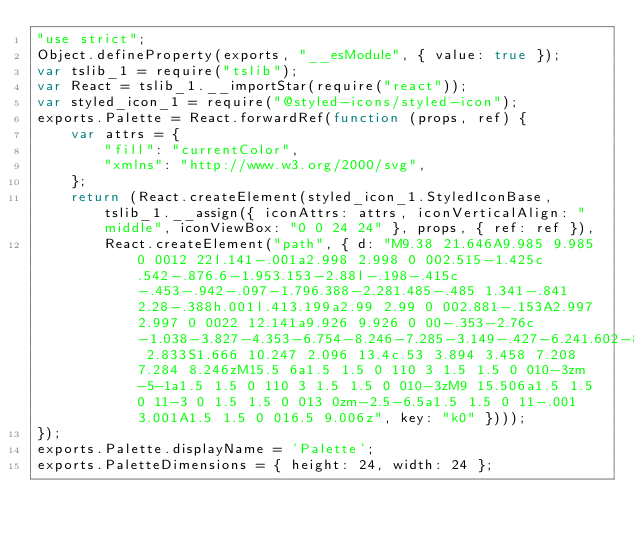<code> <loc_0><loc_0><loc_500><loc_500><_JavaScript_>"use strict";
Object.defineProperty(exports, "__esModule", { value: true });
var tslib_1 = require("tslib");
var React = tslib_1.__importStar(require("react"));
var styled_icon_1 = require("@styled-icons/styled-icon");
exports.Palette = React.forwardRef(function (props, ref) {
    var attrs = {
        "fill": "currentColor",
        "xmlns": "http://www.w3.org/2000/svg",
    };
    return (React.createElement(styled_icon_1.StyledIconBase, tslib_1.__assign({ iconAttrs: attrs, iconVerticalAlign: "middle", iconViewBox: "0 0 24 24" }, props, { ref: ref }),
        React.createElement("path", { d: "M9.38 21.646A9.985 9.985 0 0012 22l.141-.001a2.998 2.998 0 002.515-1.425c.542-.876.6-1.953.153-2.88l-.198-.415c-.453-.942-.097-1.796.388-2.281.485-.485 1.341-.841 2.28-.388h.001l.413.199a2.99 2.99 0 002.881-.153A2.997 2.997 0 0022 12.141a9.926 9.926 0 00-.353-2.76c-1.038-3.827-4.353-6.754-8.246-7.285-3.149-.427-6.241.602-8.471 2.833S1.666 10.247 2.096 13.4c.53 3.894 3.458 7.208 7.284 8.246zM15.5 6a1.5 1.5 0 110 3 1.5 1.5 0 010-3zm-5-1a1.5 1.5 0 110 3 1.5 1.5 0 010-3zM9 15.506a1.5 1.5 0 11-3 0 1.5 1.5 0 013 0zm-2.5-6.5a1.5 1.5 0 11-.001 3.001A1.5 1.5 0 016.5 9.006z", key: "k0" })));
});
exports.Palette.displayName = 'Palette';
exports.PaletteDimensions = { height: 24, width: 24 };
</code> 